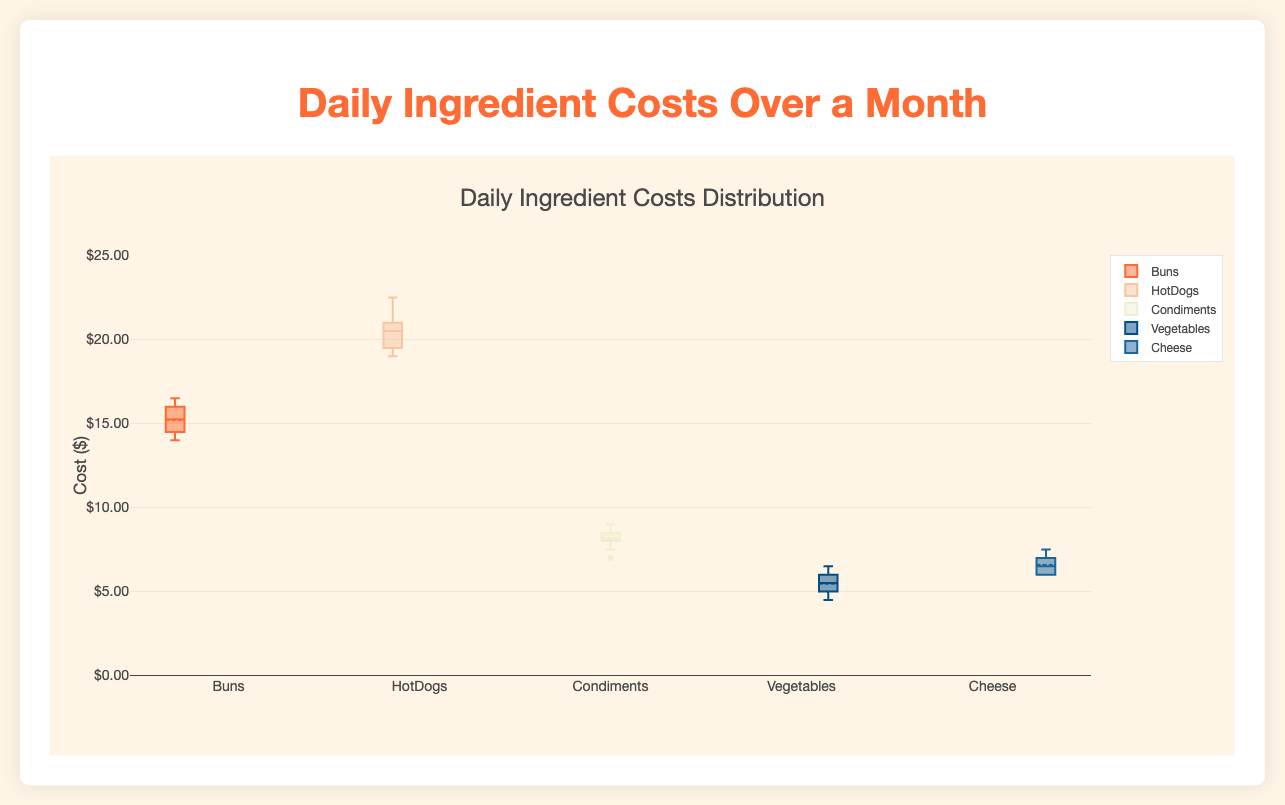What's the title of the figure? The title of the figure is clearly indicated at the top, reading "Daily Ingredient Costs Distribution."
Answer: Daily Ingredient Costs Distribution Which ingredient has the highest median cost? By examining the median lines within each box, it is clear that the HotDogs box plot has the highest median cost.
Answer: HotDogs What is the range of the y-axis? The y-axis range is shown on the left side of the plot, ranging from 0 to 25 dollars.
Answer: 0 to 25 dollars Which ingredient shows the most variability in costs? The ingredient with the largest interquartile range (IQR) and whiskers indicates the most variability. HotDogs has the highest IQR and wider whiskers compared to other ingredients.
Answer: HotDogs What is the approximate median cost for Cheese? Looking at the middle line within the Cheese box plot, the approximate median cost for Cheese is around 6.5 dollars.
Answer: 6.5 dollars Which ingredients have outliers, if any? The box plots display any outliers as individual points outside the whiskers. In this case, Condiments show a few outliers above the top whisker.
Answer: Condiments Between Buns and Vegetables, which has a higher third quartile value? By comparing the top edge of the boxes (the third quartile), Buns has a higher third quartile value than Vegetables.
Answer: Buns What is the lowest recorded daily cost for HotDogs? The lowest point on the HotDogs box plot's whiskers represents the minimum value, approximately around 19 dollars.
Answer: 19 dollars What is the interquartile range (IQR) for Condiments? The IQR is the difference between the third quartile (top edge of the box) and the first quartile (bottom edge of the box). For Condiments, the top is around 8.5 dollars and the bottom is around 7.5 dollars, giving an IQR of 1 dollar.
Answer: 1 dollar Comparing Buns and Cheese, which has a higher first quartile value? By looking at the bottom edge of each box, Buns has a higher first quartile value compared to Cheese.
Answer: Buns 